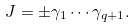Convert formula to latex. <formula><loc_0><loc_0><loc_500><loc_500>J = \pm \gamma _ { 1 } \cdots \gamma _ { q + 1 } .</formula> 